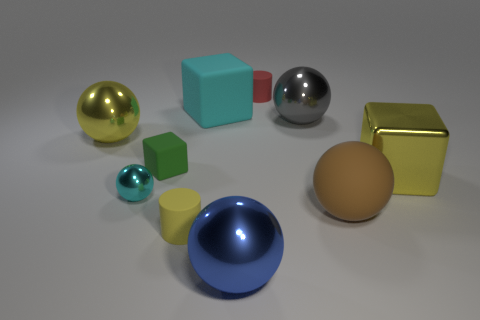Subtract all cyan balls. How many balls are left? 4 Subtract all large brown balls. How many balls are left? 4 Subtract all red spheres. Subtract all gray cylinders. How many spheres are left? 5 Subtract all cylinders. How many objects are left? 8 Add 6 big cyan rubber cubes. How many big cyan rubber cubes exist? 7 Subtract 0 cyan cylinders. How many objects are left? 10 Subtract all cyan rubber blocks. Subtract all large yellow metallic objects. How many objects are left? 7 Add 7 blue shiny balls. How many blue shiny balls are left? 8 